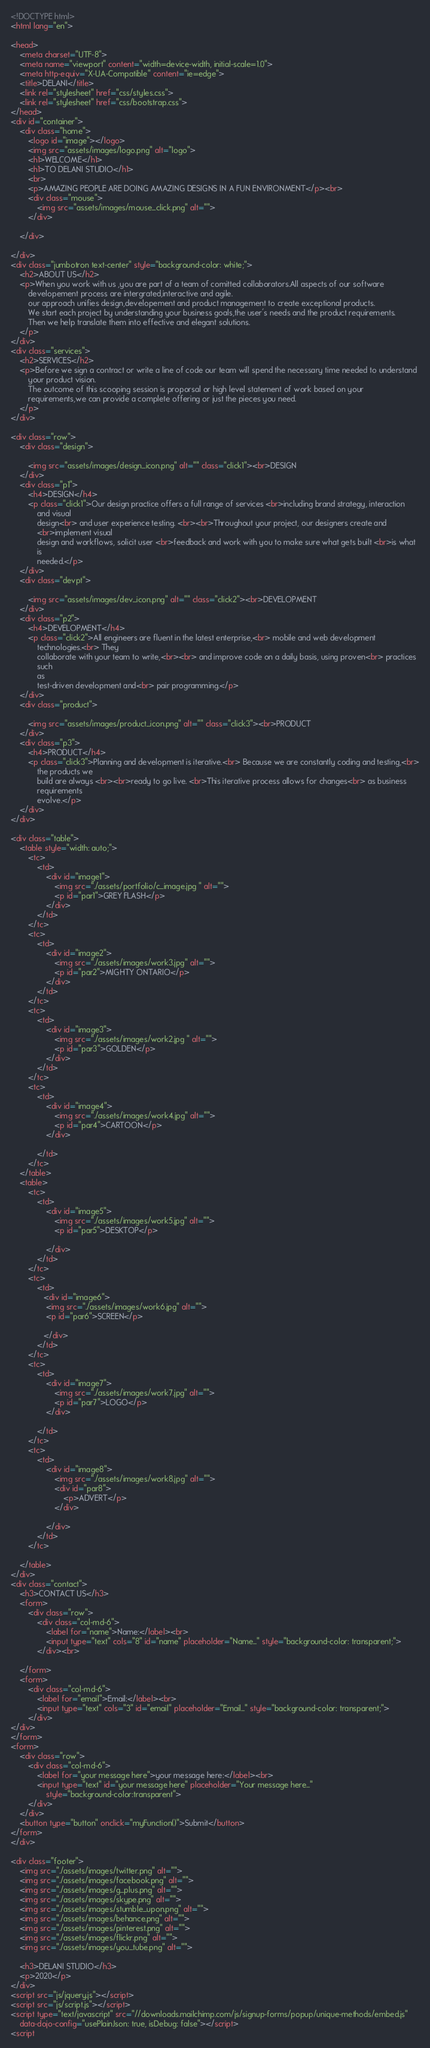Convert code to text. <code><loc_0><loc_0><loc_500><loc_500><_HTML_><!DOCTYPE html>
<html lang="en">

<head>
    <meta charset="UTF-8">
    <meta name="viewport" content="width=device-width, initial-scale=1.0">
    <meta http-equiv="X-UA-Compatible" content="ie=edge">
    <title>DELANI</title>
    <link rel="stylesheet" href="css/styles.css">
    <link rel="stylesheet" href="css/bootstrap.css">
</head>
<div id="container">
    <div class="home">
        <logo id="image"></logo>
        <img src="assets/images/logo.png" alt="logo">
        <h1>WELCOME</h1>
        <h1>TO DELANI STUDIO</h1>
        <br>
        <p>AMAZING PEOPLE ARE DOING AMAZING DESIGNS IN A FUN ENVIRONMENT</p><br>
        <div class="mouse">
            <img src="assets/images/mouse_click.png" alt="">
        </div>

    </div>

</div>
<div class="jumbotron text-center" style="background-color: white;">
    <h2>ABOUT US</h2>
    <p>When you work with us ,you are part of a team of comitted collaborators.All aspects of our software
        developement process are intergrated,interactive and agile.
        our approach unifies design,developement and product management to create exceptional products.
        We start each project by understanding your business goals,the user's needs and the product requirements.
        Then we help translate them into effective and elegant solutions.
    </p>
</div>
<div class="services">
    <h2>SERVICES</h2>
    <p>Before we sign a contract or write a line of code our team will spend the necessary time needed to understand
        your product vision.
        The outcome of this scooping session is proporsal or high level statement of work based on your
        requirements,we can provide a complete offering or just the pieces you need.
    </p>
</div>

<div class="row">
    <div class="design">

        <img src="assets/images/design_icon.png" alt="" class="click1"><br>DESIGN
    </div>
    <div class="p1">
        <h4>DESIGN</h4>
        <p class="click1">Our design practice offers a full range of services <br>including brand strategy, interaction
            and visual
            design<br> and user experience testing. <br><br>Throughout your project, our designers create and
            <br>implement visual
            design and workflows, solicit user <br>feedback and work with you to make sure what gets built <br>is what
            is
            needed.</p>
    </div>
    <div class="devpt">

        <img src="assets/images/dev_icon.png" alt="" class="click2"><br>DEVELOPMENT
    </div>
    <div class="p2">
        <h4>DEVELOPMENT</h4>
        <p class="click2">All engineers are fluent in the latest enterprise,<br> mobile and web development
            technologies.<br> They
            collaborate with your team to write,<br><br> and improve code on a daily basis, using proven<br> practices
            such
            as
            test-driven development and<br> pair programming.</p>
    </div>
    <div class="product">

        <img src="assets/images/product_icon.png" alt="" class="click3"><br>PRODUCT
    </div>
    <div class="p3">
        <h4>PRODUCT</h4>
        <p class="click3">Planning and development is iterative.<br> Because we are constantly coding and testing,<br>
            the products we
            build are always <br><br>ready to go live. <br>This iterative process allows for changes<br> as business
            requirements
            evolve.</p>
    </div>
</div>

<div class="table">
    <table style="width: auto;">
        <tc>
            <td>
                <div id="image1">
                    <img src="./assets/portfolio/c_image.jpg " alt="">
                    <p id="par1">GREY FLASH</p>
                </div>
            </td>
        </tc>
        <tc>
            <td>
                <div id="image2">
                    <img src="./assets/images/work3.jpg" alt="">
                    <p id="par2">MIGHTY ONTARIO</p>
                </div>
            </td>
        </tc>
        <tc>
            <td>
                <div id="image3">
                    <img src="./assets/images/work2.jpg " alt="">
                    <p id="par3">GOLDEN</p>
                </div>
            </td>
        </tc>
        <tc>
            <td>
                <div id="image4">
                    <img src="./assets/images/work4.jpg" alt="">
                    <p id="par4">CARTOON</p>
                </div>

            </td>
        </tc>
    </table>
    <table>
        <tc>
            <td>
                <div id="image5">
                    <img src="./assets/images/work5.jpg" alt="">
                    <p id="par5">DESKTOP</p>

                </div>
            </td>
        </tc>
        <tc>
            <td>
               <div id="image6">
                <img src="./assets/images/work6.jpg" alt="">
                <p id="par6">SCREEN</p>

               </div>
            </td>
        </tc>
        <tc>
            <td>
                <div id="image7">
                    <img src="./assets/images/work7.jpg" alt="">
                    <p id="par7">LOGO</p>
                </div>
                
            </td>
        </tc>
        <tc>
            <td>
                <div id="image8">
                    <img src="./assets/images/work8.jpg" alt="">
                    <div id="par8">
                        <p>ADVERT</p>
                    </div>
                    
                </div>
            </td>
        </tc>

    </table>
</div>
<div class="contact">
    <h3>CONTACT US</h3>
    <form>
        <div class="row">
            <div class="col-md-6">
                <label for="name">Name:</label><br>
                <input type="text" cols="8" id="name" placeholder="Name..." style="background-color: transparent;">
            </div><br>

    </form>
    <form>
        <div class="col-md-6">
            <label for="email">Email:</label><br>
            <input type="text" cols="3" id="email" placeholder="Email..." style="background-color: transparent;">
        </div>
</div>
</form>
<form>
    <div class="row">
        <div class="col-md-6">
            <label for="your message here">your message here:</label><br>
            <input type="text" id="your message here" placeholder="Your message here..."
                style="background-color:transparent">
        </div>
    </div>
    <button type="button" onclick="myFunction()">Submit</button>
</form>
</div>

<div class="footer">
    <img src="./assets/images/twitter.png" alt="">
    <img src="./assets/images/facebook.png" alt="">
    <img src="./assets/images/g_plus.png" alt="">
    <img src="./assets/images/skype.png" alt="">
    <img src="./assets/images/stumble_upon.png" alt="">
    <img src="./assets/images/behance.png" alt="">
    <img src="./assets/images/pinterest.png" alt="">
    <img src="./assets/images/flickr.png" alt="">
    <img src="./assets/images/you_tube.png" alt="">

    <h3>DELANI STUDIO</h3>
    <p>2020</p>
</div>
<script src="js/jquery.js"></script>
<script src="js/script.js"></script>
<script type="text/javascript" src="//downloads.mailchimp.com/js/signup-forms/popup/unique-methods/embed.js"
    data-dojo-config="usePlainJson: true, isDebug: false"></script>
<script</code> 